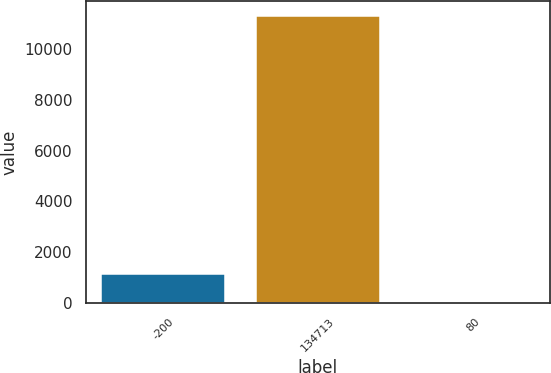Convert chart to OTSL. <chart><loc_0><loc_0><loc_500><loc_500><bar_chart><fcel>-200<fcel>134713<fcel>80<nl><fcel>1140.53<fcel>11322.5<fcel>9.2<nl></chart> 